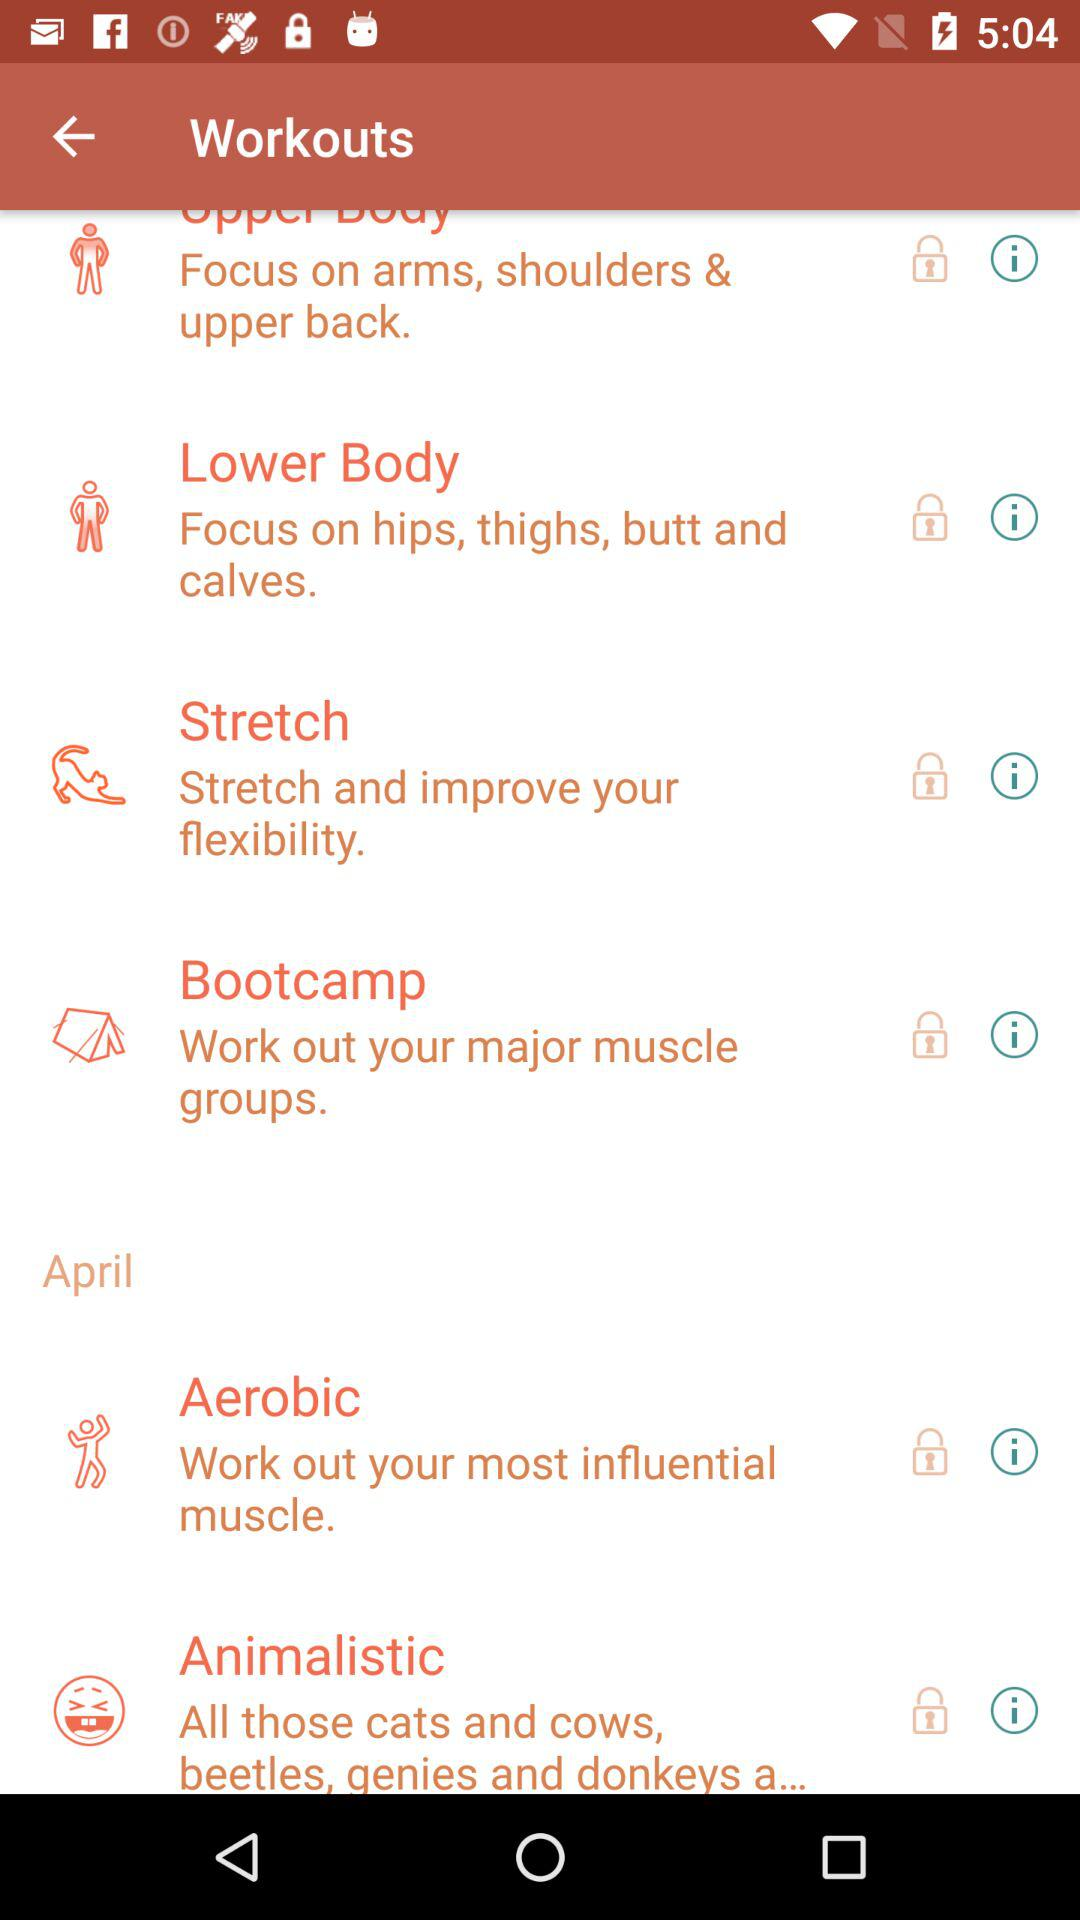Which body parts in the lower body are the emphasis of the workout? The body parts are hips, thighs, buttocks and calves. 